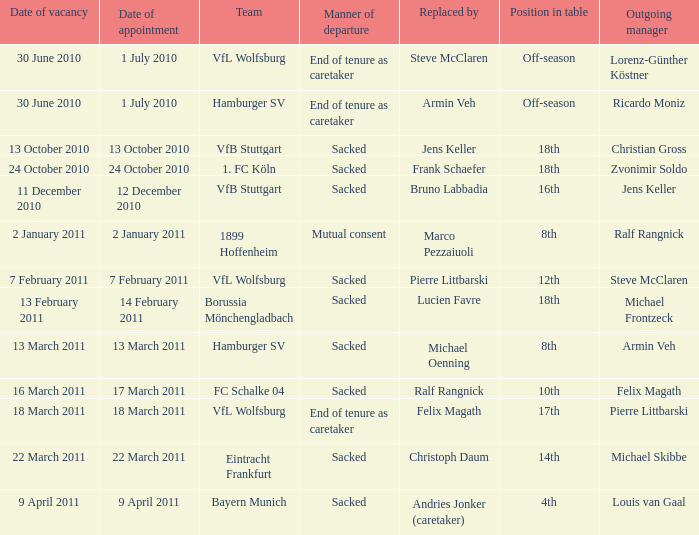Parse the table in full. {'header': ['Date of vacancy', 'Date of appointment', 'Team', 'Manner of departure', 'Replaced by', 'Position in table', 'Outgoing manager'], 'rows': [['30 June 2010', '1 July 2010', 'VfL Wolfsburg', 'End of tenure as caretaker', 'Steve McClaren', 'Off-season', 'Lorenz-Günther Köstner'], ['30 June 2010', '1 July 2010', 'Hamburger SV', 'End of tenure as caretaker', 'Armin Veh', 'Off-season', 'Ricardo Moniz'], ['13 October 2010', '13 October 2010', 'VfB Stuttgart', 'Sacked', 'Jens Keller', '18th', 'Christian Gross'], ['24 October 2010', '24 October 2010', '1. FC Köln', 'Sacked', 'Frank Schaefer', '18th', 'Zvonimir Soldo'], ['11 December 2010', '12 December 2010', 'VfB Stuttgart', 'Sacked', 'Bruno Labbadia', '16th', 'Jens Keller'], ['2 January 2011', '2 January 2011', '1899 Hoffenheim', 'Mutual consent', 'Marco Pezzaiuoli', '8th', 'Ralf Rangnick'], ['7 February 2011', '7 February 2011', 'VfL Wolfsburg', 'Sacked', 'Pierre Littbarski', '12th', 'Steve McClaren'], ['13 February 2011', '14 February 2011', 'Borussia Mönchengladbach', 'Sacked', 'Lucien Favre', '18th', 'Michael Frontzeck'], ['13 March 2011', '13 March 2011', 'Hamburger SV', 'Sacked', 'Michael Oenning', '8th', 'Armin Veh'], ['16 March 2011', '17 March 2011', 'FC Schalke 04', 'Sacked', 'Ralf Rangnick', '10th', 'Felix Magath'], ['18 March 2011', '18 March 2011', 'VfL Wolfsburg', 'End of tenure as caretaker', 'Felix Magath', '17th', 'Pierre Littbarski'], ['22 March 2011', '22 March 2011', 'Eintracht Frankfurt', 'Sacked', 'Christoph Daum', '14th', 'Michael Skibbe'], ['9 April 2011', '9 April 2011', 'Bayern Munich', 'Sacked', 'Andries Jonker (caretaker)', '4th', 'Louis van Gaal']]} When steve mcclaren is the replacer what is the manner of departure? End of tenure as caretaker. 